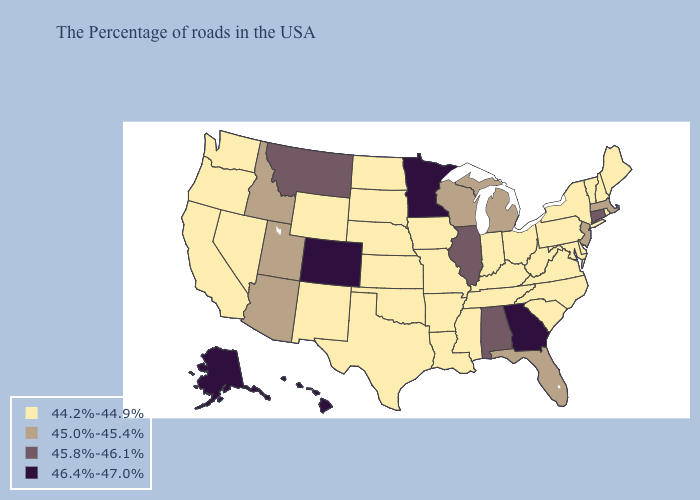Name the states that have a value in the range 46.4%-47.0%?
Short answer required. Georgia, Minnesota, Colorado, Alaska, Hawaii. Among the states that border Indiana , does Kentucky have the lowest value?
Quick response, please. Yes. Among the states that border New York , does Connecticut have the highest value?
Concise answer only. Yes. What is the value of Montana?
Write a very short answer. 45.8%-46.1%. Does the map have missing data?
Be succinct. No. Does Georgia have the highest value in the South?
Give a very brief answer. Yes. How many symbols are there in the legend?
Quick response, please. 4. What is the value of New Hampshire?
Short answer required. 44.2%-44.9%. Which states have the lowest value in the USA?
Short answer required. Maine, Rhode Island, New Hampshire, Vermont, New York, Delaware, Maryland, Pennsylvania, Virginia, North Carolina, South Carolina, West Virginia, Ohio, Kentucky, Indiana, Tennessee, Mississippi, Louisiana, Missouri, Arkansas, Iowa, Kansas, Nebraska, Oklahoma, Texas, South Dakota, North Dakota, Wyoming, New Mexico, Nevada, California, Washington, Oregon. Among the states that border Nebraska , does Colorado have the highest value?
Quick response, please. Yes. Among the states that border Nebraska , does Colorado have the highest value?
Be succinct. Yes. What is the lowest value in the USA?
Give a very brief answer. 44.2%-44.9%. Is the legend a continuous bar?
Keep it brief. No. Name the states that have a value in the range 45.0%-45.4%?
Concise answer only. Massachusetts, New Jersey, Florida, Michigan, Wisconsin, Utah, Arizona, Idaho. 